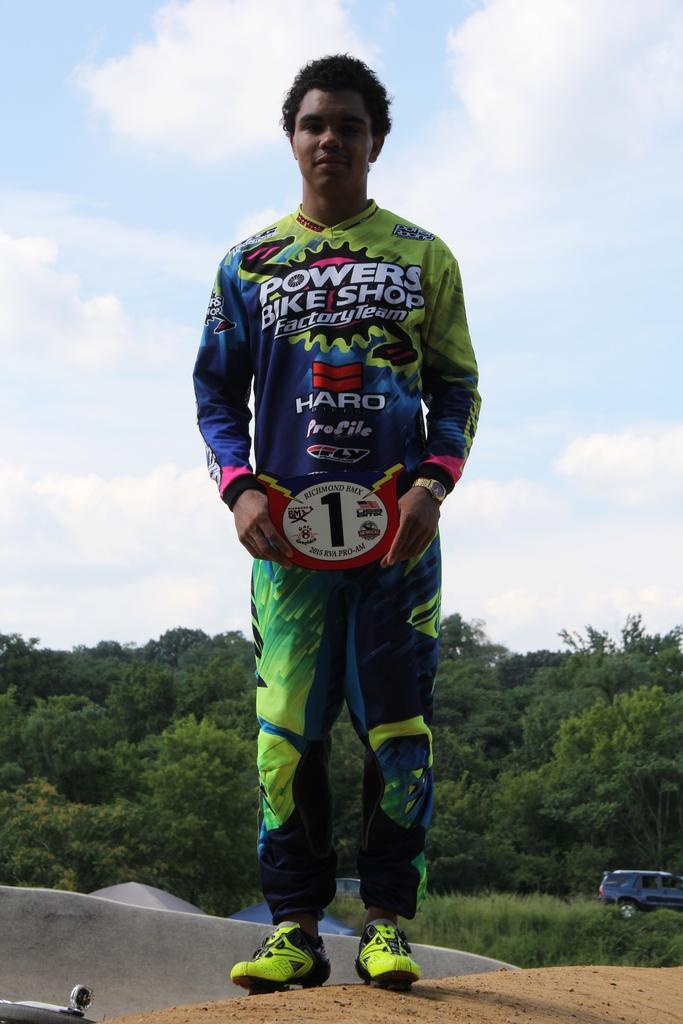<image>
Describe the image concisely. A boy is wearing a uniform for Powers Bike Shop. 